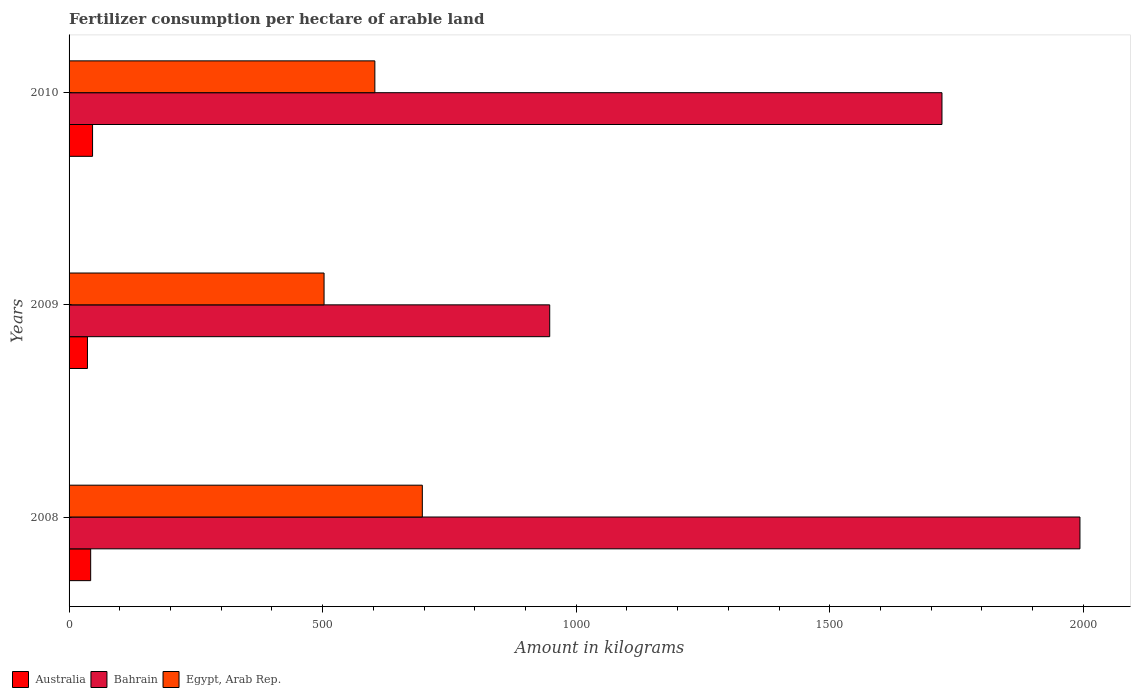How many different coloured bars are there?
Your answer should be compact. 3. Are the number of bars per tick equal to the number of legend labels?
Give a very brief answer. Yes. How many bars are there on the 3rd tick from the top?
Give a very brief answer. 3. How many bars are there on the 1st tick from the bottom?
Keep it short and to the point. 3. What is the amount of fertilizer consumption in Egypt, Arab Rep. in 2009?
Offer a very short reply. 502.83. Across all years, what is the maximum amount of fertilizer consumption in Bahrain?
Provide a succinct answer. 1993.33. Across all years, what is the minimum amount of fertilizer consumption in Bahrain?
Make the answer very short. 947.79. In which year was the amount of fertilizer consumption in Australia minimum?
Your answer should be very brief. 2009. What is the total amount of fertilizer consumption in Bahrain in the graph?
Make the answer very short. 4662.38. What is the difference between the amount of fertilizer consumption in Australia in 2008 and that in 2009?
Give a very brief answer. 6.35. What is the difference between the amount of fertilizer consumption in Egypt, Arab Rep. in 2009 and the amount of fertilizer consumption in Bahrain in 2008?
Provide a succinct answer. -1490.51. What is the average amount of fertilizer consumption in Australia per year?
Provide a succinct answer. 41.72. In the year 2010, what is the difference between the amount of fertilizer consumption in Egypt, Arab Rep. and amount of fertilizer consumption in Australia?
Provide a succinct answer. 556.67. What is the ratio of the amount of fertilizer consumption in Egypt, Arab Rep. in 2008 to that in 2009?
Ensure brevity in your answer.  1.39. Is the amount of fertilizer consumption in Egypt, Arab Rep. in 2008 less than that in 2010?
Provide a succinct answer. No. What is the difference between the highest and the second highest amount of fertilizer consumption in Bahrain?
Give a very brief answer. 272.08. What is the difference between the highest and the lowest amount of fertilizer consumption in Bahrain?
Make the answer very short. 1045.54. In how many years, is the amount of fertilizer consumption in Egypt, Arab Rep. greater than the average amount of fertilizer consumption in Egypt, Arab Rep. taken over all years?
Ensure brevity in your answer.  2. What does the 1st bar from the top in 2009 represents?
Give a very brief answer. Egypt, Arab Rep. What does the 2nd bar from the bottom in 2008 represents?
Provide a succinct answer. Bahrain. How many bars are there?
Your answer should be compact. 9. What is the difference between two consecutive major ticks on the X-axis?
Ensure brevity in your answer.  500. Are the values on the major ticks of X-axis written in scientific E-notation?
Ensure brevity in your answer.  No. Does the graph contain grids?
Your answer should be very brief. No. Where does the legend appear in the graph?
Provide a short and direct response. Bottom left. How are the legend labels stacked?
Ensure brevity in your answer.  Horizontal. What is the title of the graph?
Make the answer very short. Fertilizer consumption per hectare of arable land. Does "OECD members" appear as one of the legend labels in the graph?
Your answer should be compact. No. What is the label or title of the X-axis?
Your response must be concise. Amount in kilograms. What is the Amount in kilograms in Australia in 2008?
Provide a short and direct response. 42.6. What is the Amount in kilograms of Bahrain in 2008?
Make the answer very short. 1993.33. What is the Amount in kilograms in Egypt, Arab Rep. in 2008?
Your response must be concise. 696.59. What is the Amount in kilograms in Australia in 2009?
Offer a very short reply. 36.25. What is the Amount in kilograms of Bahrain in 2009?
Offer a terse response. 947.79. What is the Amount in kilograms in Egypt, Arab Rep. in 2009?
Offer a very short reply. 502.83. What is the Amount in kilograms in Australia in 2010?
Keep it short and to the point. 46.32. What is the Amount in kilograms of Bahrain in 2010?
Offer a terse response. 1721.25. What is the Amount in kilograms of Egypt, Arab Rep. in 2010?
Offer a very short reply. 602.99. Across all years, what is the maximum Amount in kilograms in Australia?
Ensure brevity in your answer.  46.32. Across all years, what is the maximum Amount in kilograms in Bahrain?
Offer a terse response. 1993.33. Across all years, what is the maximum Amount in kilograms in Egypt, Arab Rep.?
Offer a very short reply. 696.59. Across all years, what is the minimum Amount in kilograms of Australia?
Provide a succinct answer. 36.25. Across all years, what is the minimum Amount in kilograms in Bahrain?
Ensure brevity in your answer.  947.79. Across all years, what is the minimum Amount in kilograms of Egypt, Arab Rep.?
Ensure brevity in your answer.  502.83. What is the total Amount in kilograms of Australia in the graph?
Ensure brevity in your answer.  125.17. What is the total Amount in kilograms of Bahrain in the graph?
Provide a succinct answer. 4662.38. What is the total Amount in kilograms in Egypt, Arab Rep. in the graph?
Your answer should be compact. 1802.4. What is the difference between the Amount in kilograms of Australia in 2008 and that in 2009?
Ensure brevity in your answer.  6.35. What is the difference between the Amount in kilograms in Bahrain in 2008 and that in 2009?
Your response must be concise. 1045.54. What is the difference between the Amount in kilograms of Egypt, Arab Rep. in 2008 and that in 2009?
Make the answer very short. 193.77. What is the difference between the Amount in kilograms in Australia in 2008 and that in 2010?
Your response must be concise. -3.71. What is the difference between the Amount in kilograms of Bahrain in 2008 and that in 2010?
Keep it short and to the point. 272.08. What is the difference between the Amount in kilograms in Egypt, Arab Rep. in 2008 and that in 2010?
Make the answer very short. 93.61. What is the difference between the Amount in kilograms of Australia in 2009 and that in 2010?
Make the answer very short. -10.07. What is the difference between the Amount in kilograms of Bahrain in 2009 and that in 2010?
Make the answer very short. -773.46. What is the difference between the Amount in kilograms in Egypt, Arab Rep. in 2009 and that in 2010?
Give a very brief answer. -100.16. What is the difference between the Amount in kilograms of Australia in 2008 and the Amount in kilograms of Bahrain in 2009?
Your response must be concise. -905.19. What is the difference between the Amount in kilograms in Australia in 2008 and the Amount in kilograms in Egypt, Arab Rep. in 2009?
Your answer should be compact. -460.22. What is the difference between the Amount in kilograms in Bahrain in 2008 and the Amount in kilograms in Egypt, Arab Rep. in 2009?
Your answer should be very brief. 1490.51. What is the difference between the Amount in kilograms of Australia in 2008 and the Amount in kilograms of Bahrain in 2010?
Offer a terse response. -1678.65. What is the difference between the Amount in kilograms of Australia in 2008 and the Amount in kilograms of Egypt, Arab Rep. in 2010?
Ensure brevity in your answer.  -560.38. What is the difference between the Amount in kilograms of Bahrain in 2008 and the Amount in kilograms of Egypt, Arab Rep. in 2010?
Your answer should be very brief. 1390.35. What is the difference between the Amount in kilograms in Australia in 2009 and the Amount in kilograms in Bahrain in 2010?
Ensure brevity in your answer.  -1685. What is the difference between the Amount in kilograms in Australia in 2009 and the Amount in kilograms in Egypt, Arab Rep. in 2010?
Your answer should be very brief. -566.74. What is the difference between the Amount in kilograms of Bahrain in 2009 and the Amount in kilograms of Egypt, Arab Rep. in 2010?
Your answer should be very brief. 344.81. What is the average Amount in kilograms of Australia per year?
Provide a short and direct response. 41.72. What is the average Amount in kilograms of Bahrain per year?
Make the answer very short. 1554.13. What is the average Amount in kilograms of Egypt, Arab Rep. per year?
Your answer should be very brief. 600.8. In the year 2008, what is the difference between the Amount in kilograms in Australia and Amount in kilograms in Bahrain?
Your answer should be very brief. -1950.73. In the year 2008, what is the difference between the Amount in kilograms of Australia and Amount in kilograms of Egypt, Arab Rep.?
Give a very brief answer. -653.99. In the year 2008, what is the difference between the Amount in kilograms of Bahrain and Amount in kilograms of Egypt, Arab Rep.?
Offer a terse response. 1296.74. In the year 2009, what is the difference between the Amount in kilograms of Australia and Amount in kilograms of Bahrain?
Make the answer very short. -911.54. In the year 2009, what is the difference between the Amount in kilograms of Australia and Amount in kilograms of Egypt, Arab Rep.?
Keep it short and to the point. -466.57. In the year 2009, what is the difference between the Amount in kilograms of Bahrain and Amount in kilograms of Egypt, Arab Rep.?
Your answer should be very brief. 444.97. In the year 2010, what is the difference between the Amount in kilograms in Australia and Amount in kilograms in Bahrain?
Offer a very short reply. -1674.93. In the year 2010, what is the difference between the Amount in kilograms in Australia and Amount in kilograms in Egypt, Arab Rep.?
Offer a very short reply. -556.67. In the year 2010, what is the difference between the Amount in kilograms of Bahrain and Amount in kilograms of Egypt, Arab Rep.?
Give a very brief answer. 1118.26. What is the ratio of the Amount in kilograms of Australia in 2008 to that in 2009?
Make the answer very short. 1.18. What is the ratio of the Amount in kilograms in Bahrain in 2008 to that in 2009?
Provide a succinct answer. 2.1. What is the ratio of the Amount in kilograms of Egypt, Arab Rep. in 2008 to that in 2009?
Provide a succinct answer. 1.39. What is the ratio of the Amount in kilograms of Australia in 2008 to that in 2010?
Your answer should be very brief. 0.92. What is the ratio of the Amount in kilograms of Bahrain in 2008 to that in 2010?
Ensure brevity in your answer.  1.16. What is the ratio of the Amount in kilograms of Egypt, Arab Rep. in 2008 to that in 2010?
Provide a succinct answer. 1.16. What is the ratio of the Amount in kilograms in Australia in 2009 to that in 2010?
Ensure brevity in your answer.  0.78. What is the ratio of the Amount in kilograms in Bahrain in 2009 to that in 2010?
Your response must be concise. 0.55. What is the ratio of the Amount in kilograms of Egypt, Arab Rep. in 2009 to that in 2010?
Provide a short and direct response. 0.83. What is the difference between the highest and the second highest Amount in kilograms of Australia?
Offer a terse response. 3.71. What is the difference between the highest and the second highest Amount in kilograms of Bahrain?
Offer a very short reply. 272.08. What is the difference between the highest and the second highest Amount in kilograms in Egypt, Arab Rep.?
Offer a terse response. 93.61. What is the difference between the highest and the lowest Amount in kilograms of Australia?
Offer a very short reply. 10.07. What is the difference between the highest and the lowest Amount in kilograms in Bahrain?
Ensure brevity in your answer.  1045.54. What is the difference between the highest and the lowest Amount in kilograms of Egypt, Arab Rep.?
Keep it short and to the point. 193.77. 